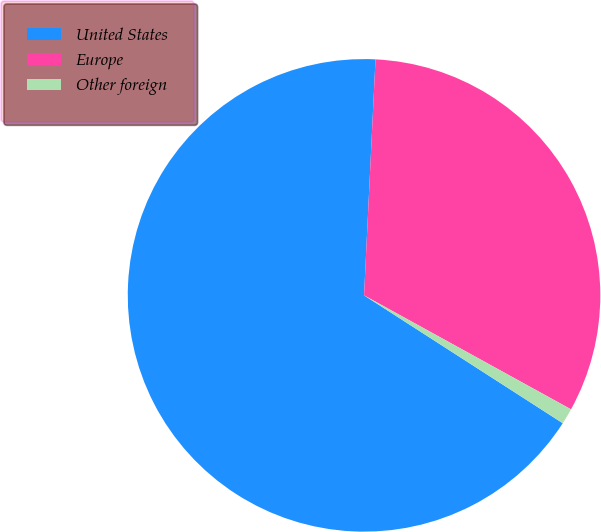Convert chart to OTSL. <chart><loc_0><loc_0><loc_500><loc_500><pie_chart><fcel>United States<fcel>Europe<fcel>Other foreign<nl><fcel>66.67%<fcel>32.24%<fcel>1.09%<nl></chart> 